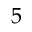<formula> <loc_0><loc_0><loc_500><loc_500>5</formula> 